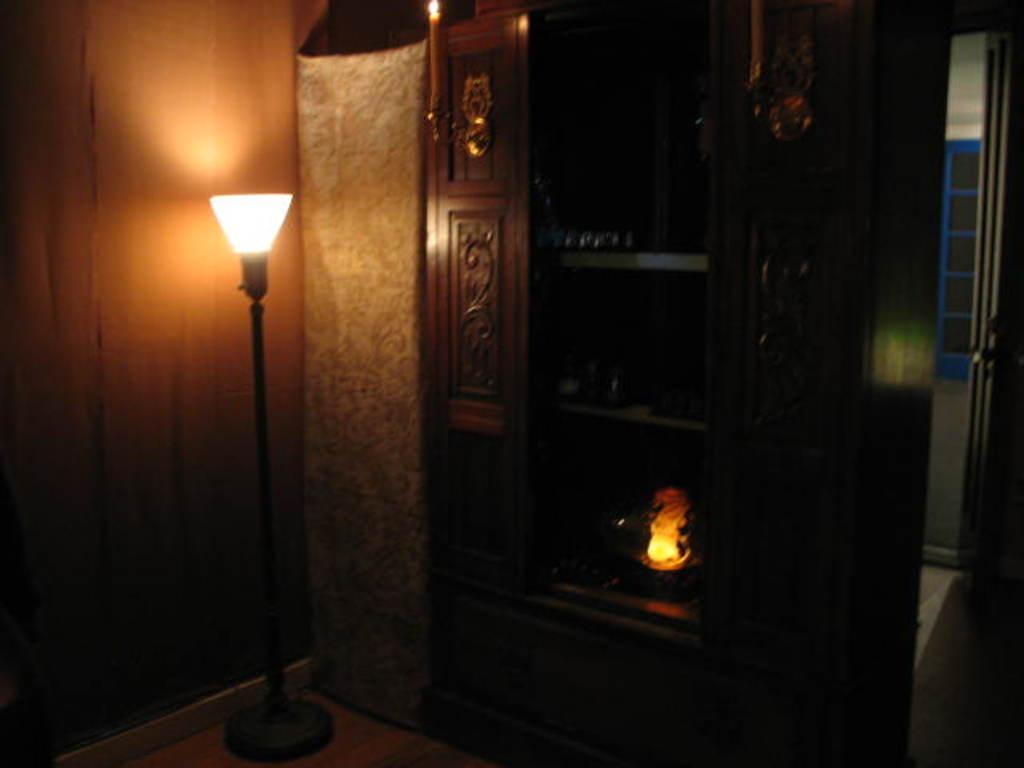Can you describe this image briefly? In the center of the image we can see a cupboard. On the left side of the image we can see a lamp, wall, curtain are present. On the right side of the image a window is there. At the bottom of the image floor is present. 